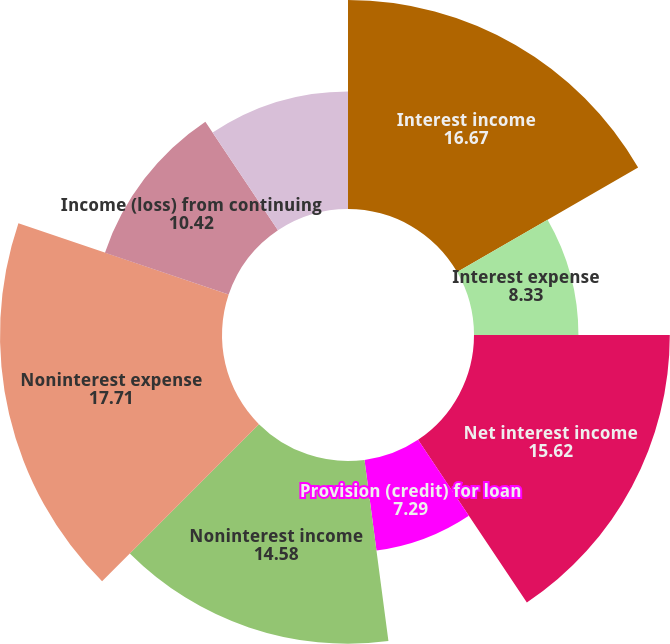Convert chart. <chart><loc_0><loc_0><loc_500><loc_500><pie_chart><fcel>Interest income<fcel>Interest expense<fcel>Net interest income<fcel>Provision (credit) for loan<fcel>Noninterest income<fcel>Noninterest expense<fcel>Income (loss) from continuing<fcel>Net income (loss) attributable<nl><fcel>16.67%<fcel>8.33%<fcel>15.62%<fcel>7.29%<fcel>14.58%<fcel>17.71%<fcel>10.42%<fcel>9.38%<nl></chart> 